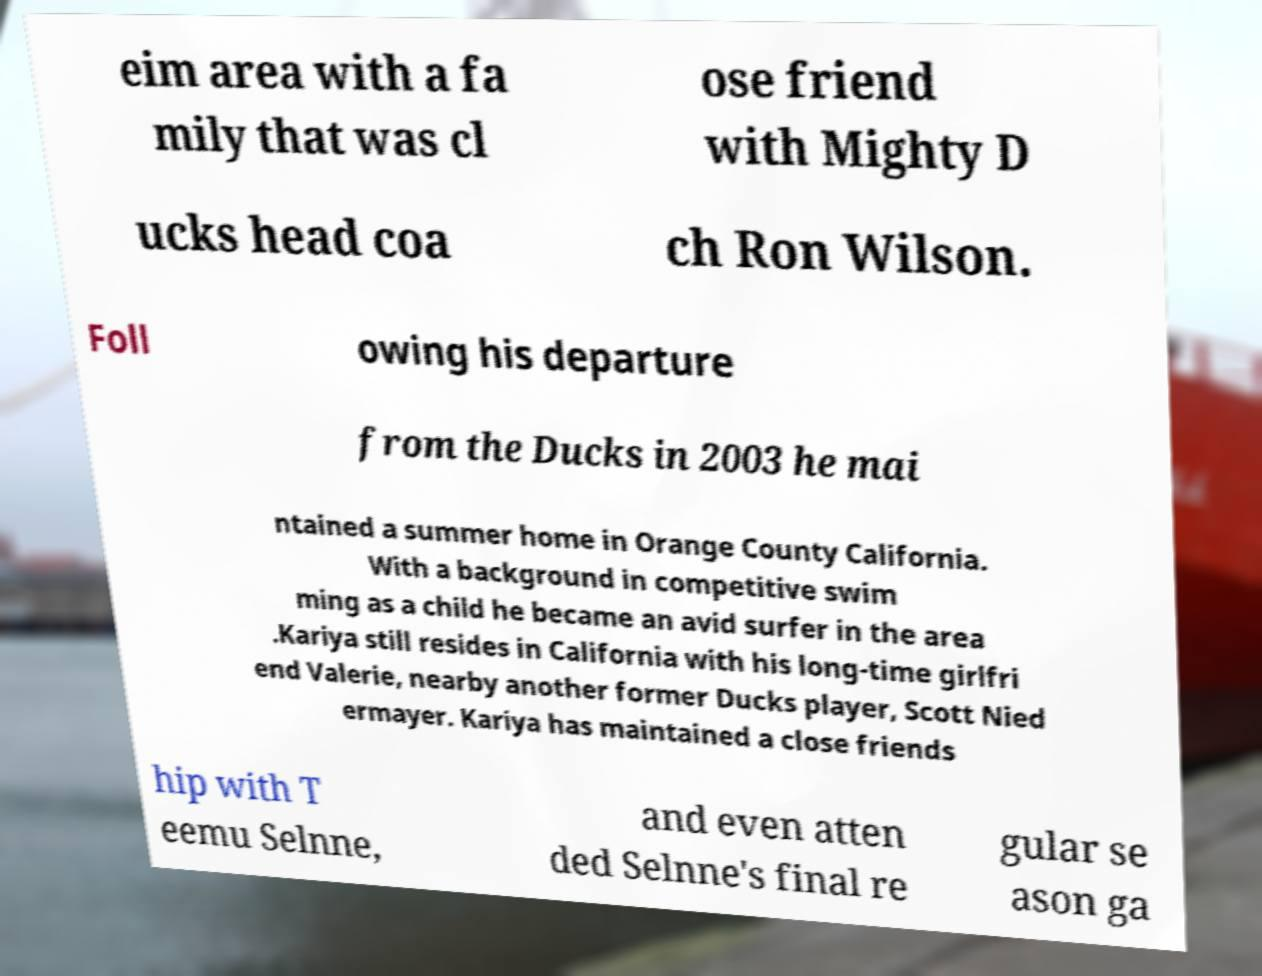What messages or text are displayed in this image? I need them in a readable, typed format. eim area with a fa mily that was cl ose friend with Mighty D ucks head coa ch Ron Wilson. Foll owing his departure from the Ducks in 2003 he mai ntained a summer home in Orange County California. With a background in competitive swim ming as a child he became an avid surfer in the area .Kariya still resides in California with his long-time girlfri end Valerie, nearby another former Ducks player, Scott Nied ermayer. Kariya has maintained a close friends hip with T eemu Selnne, and even atten ded Selnne's final re gular se ason ga 